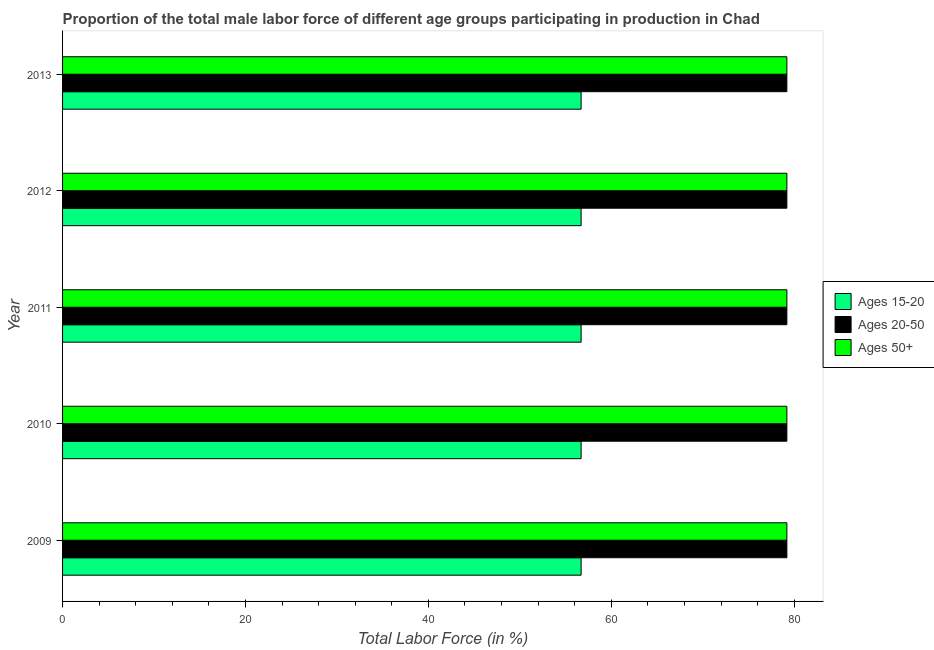How many different coloured bars are there?
Your answer should be compact. 3. What is the label of the 3rd group of bars from the top?
Give a very brief answer. 2011. In how many cases, is the number of bars for a given year not equal to the number of legend labels?
Give a very brief answer. 0. What is the percentage of male labor force within the age group 15-20 in 2010?
Provide a succinct answer. 56.7. Across all years, what is the maximum percentage of male labor force above age 50?
Make the answer very short. 79.2. Across all years, what is the minimum percentage of male labor force within the age group 20-50?
Your answer should be compact. 79.2. In which year was the percentage of male labor force above age 50 maximum?
Provide a short and direct response. 2009. In which year was the percentage of male labor force above age 50 minimum?
Your answer should be very brief. 2009. What is the total percentage of male labor force above age 50 in the graph?
Your answer should be very brief. 396. What is the difference between the percentage of male labor force within the age group 15-20 in 2010 and the percentage of male labor force within the age group 20-50 in 2011?
Your answer should be very brief. -22.5. What is the average percentage of male labor force within the age group 20-50 per year?
Keep it short and to the point. 79.2. In how many years, is the percentage of male labor force within the age group 15-20 greater than 36 %?
Your response must be concise. 5. Is the difference between the percentage of male labor force above age 50 in 2009 and 2013 greater than the difference between the percentage of male labor force within the age group 20-50 in 2009 and 2013?
Make the answer very short. No. What is the difference between the highest and the second highest percentage of male labor force within the age group 20-50?
Your answer should be compact. 0. What is the difference between the highest and the lowest percentage of male labor force above age 50?
Offer a very short reply. 0. Is the sum of the percentage of male labor force within the age group 20-50 in 2012 and 2013 greater than the maximum percentage of male labor force above age 50 across all years?
Make the answer very short. Yes. What does the 2nd bar from the top in 2009 represents?
Your answer should be very brief. Ages 20-50. What does the 1st bar from the bottom in 2013 represents?
Make the answer very short. Ages 15-20. Are all the bars in the graph horizontal?
Your answer should be compact. Yes. How many years are there in the graph?
Provide a short and direct response. 5. What is the difference between two consecutive major ticks on the X-axis?
Keep it short and to the point. 20. Does the graph contain any zero values?
Give a very brief answer. No. Where does the legend appear in the graph?
Make the answer very short. Center right. How many legend labels are there?
Offer a terse response. 3. What is the title of the graph?
Offer a terse response. Proportion of the total male labor force of different age groups participating in production in Chad. Does "Financial account" appear as one of the legend labels in the graph?
Your answer should be very brief. No. What is the label or title of the X-axis?
Offer a very short reply. Total Labor Force (in %). What is the label or title of the Y-axis?
Offer a very short reply. Year. What is the Total Labor Force (in %) in Ages 15-20 in 2009?
Your response must be concise. 56.7. What is the Total Labor Force (in %) in Ages 20-50 in 2009?
Give a very brief answer. 79.2. What is the Total Labor Force (in %) of Ages 50+ in 2009?
Provide a succinct answer. 79.2. What is the Total Labor Force (in %) of Ages 15-20 in 2010?
Your response must be concise. 56.7. What is the Total Labor Force (in %) in Ages 20-50 in 2010?
Your response must be concise. 79.2. What is the Total Labor Force (in %) in Ages 50+ in 2010?
Your answer should be compact. 79.2. What is the Total Labor Force (in %) of Ages 15-20 in 2011?
Ensure brevity in your answer.  56.7. What is the Total Labor Force (in %) of Ages 20-50 in 2011?
Make the answer very short. 79.2. What is the Total Labor Force (in %) of Ages 50+ in 2011?
Keep it short and to the point. 79.2. What is the Total Labor Force (in %) in Ages 15-20 in 2012?
Provide a short and direct response. 56.7. What is the Total Labor Force (in %) in Ages 20-50 in 2012?
Keep it short and to the point. 79.2. What is the Total Labor Force (in %) of Ages 50+ in 2012?
Give a very brief answer. 79.2. What is the Total Labor Force (in %) in Ages 15-20 in 2013?
Your response must be concise. 56.7. What is the Total Labor Force (in %) of Ages 20-50 in 2013?
Your answer should be compact. 79.2. What is the Total Labor Force (in %) in Ages 50+ in 2013?
Offer a very short reply. 79.2. Across all years, what is the maximum Total Labor Force (in %) in Ages 15-20?
Ensure brevity in your answer.  56.7. Across all years, what is the maximum Total Labor Force (in %) in Ages 20-50?
Make the answer very short. 79.2. Across all years, what is the maximum Total Labor Force (in %) in Ages 50+?
Your response must be concise. 79.2. Across all years, what is the minimum Total Labor Force (in %) of Ages 15-20?
Keep it short and to the point. 56.7. Across all years, what is the minimum Total Labor Force (in %) of Ages 20-50?
Provide a succinct answer. 79.2. Across all years, what is the minimum Total Labor Force (in %) of Ages 50+?
Offer a very short reply. 79.2. What is the total Total Labor Force (in %) in Ages 15-20 in the graph?
Provide a succinct answer. 283.5. What is the total Total Labor Force (in %) in Ages 20-50 in the graph?
Provide a short and direct response. 396. What is the total Total Labor Force (in %) of Ages 50+ in the graph?
Ensure brevity in your answer.  396. What is the difference between the Total Labor Force (in %) of Ages 15-20 in 2009 and that in 2010?
Ensure brevity in your answer.  0. What is the difference between the Total Labor Force (in %) of Ages 50+ in 2009 and that in 2011?
Provide a short and direct response. 0. What is the difference between the Total Labor Force (in %) of Ages 15-20 in 2009 and that in 2012?
Ensure brevity in your answer.  0. What is the difference between the Total Labor Force (in %) in Ages 20-50 in 2009 and that in 2012?
Give a very brief answer. 0. What is the difference between the Total Labor Force (in %) of Ages 15-20 in 2009 and that in 2013?
Offer a very short reply. 0. What is the difference between the Total Labor Force (in %) in Ages 50+ in 2009 and that in 2013?
Provide a short and direct response. 0. What is the difference between the Total Labor Force (in %) of Ages 15-20 in 2010 and that in 2013?
Your answer should be compact. 0. What is the difference between the Total Labor Force (in %) in Ages 50+ in 2010 and that in 2013?
Keep it short and to the point. 0. What is the difference between the Total Labor Force (in %) of Ages 20-50 in 2011 and that in 2012?
Your response must be concise. 0. What is the difference between the Total Labor Force (in %) in Ages 15-20 in 2011 and that in 2013?
Give a very brief answer. 0. What is the difference between the Total Labor Force (in %) of Ages 20-50 in 2011 and that in 2013?
Offer a terse response. 0. What is the difference between the Total Labor Force (in %) of Ages 50+ in 2011 and that in 2013?
Ensure brevity in your answer.  0. What is the difference between the Total Labor Force (in %) of Ages 15-20 in 2012 and that in 2013?
Your answer should be very brief. 0. What is the difference between the Total Labor Force (in %) of Ages 20-50 in 2012 and that in 2013?
Your answer should be very brief. 0. What is the difference between the Total Labor Force (in %) of Ages 15-20 in 2009 and the Total Labor Force (in %) of Ages 20-50 in 2010?
Ensure brevity in your answer.  -22.5. What is the difference between the Total Labor Force (in %) in Ages 15-20 in 2009 and the Total Labor Force (in %) in Ages 50+ in 2010?
Ensure brevity in your answer.  -22.5. What is the difference between the Total Labor Force (in %) of Ages 15-20 in 2009 and the Total Labor Force (in %) of Ages 20-50 in 2011?
Your answer should be very brief. -22.5. What is the difference between the Total Labor Force (in %) in Ages 15-20 in 2009 and the Total Labor Force (in %) in Ages 50+ in 2011?
Your answer should be very brief. -22.5. What is the difference between the Total Labor Force (in %) of Ages 20-50 in 2009 and the Total Labor Force (in %) of Ages 50+ in 2011?
Keep it short and to the point. 0. What is the difference between the Total Labor Force (in %) of Ages 15-20 in 2009 and the Total Labor Force (in %) of Ages 20-50 in 2012?
Your answer should be very brief. -22.5. What is the difference between the Total Labor Force (in %) of Ages 15-20 in 2009 and the Total Labor Force (in %) of Ages 50+ in 2012?
Provide a short and direct response. -22.5. What is the difference between the Total Labor Force (in %) of Ages 20-50 in 2009 and the Total Labor Force (in %) of Ages 50+ in 2012?
Provide a succinct answer. 0. What is the difference between the Total Labor Force (in %) of Ages 15-20 in 2009 and the Total Labor Force (in %) of Ages 20-50 in 2013?
Give a very brief answer. -22.5. What is the difference between the Total Labor Force (in %) of Ages 15-20 in 2009 and the Total Labor Force (in %) of Ages 50+ in 2013?
Provide a succinct answer. -22.5. What is the difference between the Total Labor Force (in %) in Ages 15-20 in 2010 and the Total Labor Force (in %) in Ages 20-50 in 2011?
Your answer should be very brief. -22.5. What is the difference between the Total Labor Force (in %) in Ages 15-20 in 2010 and the Total Labor Force (in %) in Ages 50+ in 2011?
Give a very brief answer. -22.5. What is the difference between the Total Labor Force (in %) of Ages 20-50 in 2010 and the Total Labor Force (in %) of Ages 50+ in 2011?
Your response must be concise. 0. What is the difference between the Total Labor Force (in %) in Ages 15-20 in 2010 and the Total Labor Force (in %) in Ages 20-50 in 2012?
Give a very brief answer. -22.5. What is the difference between the Total Labor Force (in %) of Ages 15-20 in 2010 and the Total Labor Force (in %) of Ages 50+ in 2012?
Offer a very short reply. -22.5. What is the difference between the Total Labor Force (in %) in Ages 20-50 in 2010 and the Total Labor Force (in %) in Ages 50+ in 2012?
Offer a terse response. 0. What is the difference between the Total Labor Force (in %) in Ages 15-20 in 2010 and the Total Labor Force (in %) in Ages 20-50 in 2013?
Provide a succinct answer. -22.5. What is the difference between the Total Labor Force (in %) of Ages 15-20 in 2010 and the Total Labor Force (in %) of Ages 50+ in 2013?
Offer a very short reply. -22.5. What is the difference between the Total Labor Force (in %) in Ages 15-20 in 2011 and the Total Labor Force (in %) in Ages 20-50 in 2012?
Your answer should be very brief. -22.5. What is the difference between the Total Labor Force (in %) of Ages 15-20 in 2011 and the Total Labor Force (in %) of Ages 50+ in 2012?
Your answer should be compact. -22.5. What is the difference between the Total Labor Force (in %) of Ages 20-50 in 2011 and the Total Labor Force (in %) of Ages 50+ in 2012?
Keep it short and to the point. 0. What is the difference between the Total Labor Force (in %) of Ages 15-20 in 2011 and the Total Labor Force (in %) of Ages 20-50 in 2013?
Your answer should be compact. -22.5. What is the difference between the Total Labor Force (in %) in Ages 15-20 in 2011 and the Total Labor Force (in %) in Ages 50+ in 2013?
Your response must be concise. -22.5. What is the difference between the Total Labor Force (in %) of Ages 20-50 in 2011 and the Total Labor Force (in %) of Ages 50+ in 2013?
Offer a very short reply. 0. What is the difference between the Total Labor Force (in %) in Ages 15-20 in 2012 and the Total Labor Force (in %) in Ages 20-50 in 2013?
Give a very brief answer. -22.5. What is the difference between the Total Labor Force (in %) in Ages 15-20 in 2012 and the Total Labor Force (in %) in Ages 50+ in 2013?
Your response must be concise. -22.5. What is the difference between the Total Labor Force (in %) of Ages 20-50 in 2012 and the Total Labor Force (in %) of Ages 50+ in 2013?
Provide a succinct answer. 0. What is the average Total Labor Force (in %) of Ages 15-20 per year?
Keep it short and to the point. 56.7. What is the average Total Labor Force (in %) of Ages 20-50 per year?
Your response must be concise. 79.2. What is the average Total Labor Force (in %) of Ages 50+ per year?
Provide a short and direct response. 79.2. In the year 2009, what is the difference between the Total Labor Force (in %) of Ages 15-20 and Total Labor Force (in %) of Ages 20-50?
Give a very brief answer. -22.5. In the year 2009, what is the difference between the Total Labor Force (in %) in Ages 15-20 and Total Labor Force (in %) in Ages 50+?
Your answer should be very brief. -22.5. In the year 2009, what is the difference between the Total Labor Force (in %) of Ages 20-50 and Total Labor Force (in %) of Ages 50+?
Ensure brevity in your answer.  0. In the year 2010, what is the difference between the Total Labor Force (in %) of Ages 15-20 and Total Labor Force (in %) of Ages 20-50?
Keep it short and to the point. -22.5. In the year 2010, what is the difference between the Total Labor Force (in %) of Ages 15-20 and Total Labor Force (in %) of Ages 50+?
Give a very brief answer. -22.5. In the year 2010, what is the difference between the Total Labor Force (in %) of Ages 20-50 and Total Labor Force (in %) of Ages 50+?
Keep it short and to the point. 0. In the year 2011, what is the difference between the Total Labor Force (in %) in Ages 15-20 and Total Labor Force (in %) in Ages 20-50?
Offer a terse response. -22.5. In the year 2011, what is the difference between the Total Labor Force (in %) in Ages 15-20 and Total Labor Force (in %) in Ages 50+?
Offer a terse response. -22.5. In the year 2012, what is the difference between the Total Labor Force (in %) of Ages 15-20 and Total Labor Force (in %) of Ages 20-50?
Keep it short and to the point. -22.5. In the year 2012, what is the difference between the Total Labor Force (in %) in Ages 15-20 and Total Labor Force (in %) in Ages 50+?
Make the answer very short. -22.5. In the year 2012, what is the difference between the Total Labor Force (in %) of Ages 20-50 and Total Labor Force (in %) of Ages 50+?
Make the answer very short. 0. In the year 2013, what is the difference between the Total Labor Force (in %) in Ages 15-20 and Total Labor Force (in %) in Ages 20-50?
Keep it short and to the point. -22.5. In the year 2013, what is the difference between the Total Labor Force (in %) of Ages 15-20 and Total Labor Force (in %) of Ages 50+?
Provide a short and direct response. -22.5. In the year 2013, what is the difference between the Total Labor Force (in %) in Ages 20-50 and Total Labor Force (in %) in Ages 50+?
Your response must be concise. 0. What is the ratio of the Total Labor Force (in %) of Ages 15-20 in 2009 to that in 2010?
Offer a terse response. 1. What is the ratio of the Total Labor Force (in %) in Ages 20-50 in 2009 to that in 2010?
Give a very brief answer. 1. What is the ratio of the Total Labor Force (in %) of Ages 50+ in 2009 to that in 2010?
Your answer should be compact. 1. What is the ratio of the Total Labor Force (in %) in Ages 20-50 in 2009 to that in 2011?
Provide a succinct answer. 1. What is the ratio of the Total Labor Force (in %) of Ages 50+ in 2009 to that in 2011?
Give a very brief answer. 1. What is the ratio of the Total Labor Force (in %) of Ages 20-50 in 2009 to that in 2012?
Keep it short and to the point. 1. What is the ratio of the Total Labor Force (in %) of Ages 50+ in 2009 to that in 2012?
Make the answer very short. 1. What is the ratio of the Total Labor Force (in %) in Ages 15-20 in 2009 to that in 2013?
Your answer should be very brief. 1. What is the ratio of the Total Labor Force (in %) in Ages 15-20 in 2010 to that in 2011?
Your response must be concise. 1. What is the ratio of the Total Labor Force (in %) of Ages 20-50 in 2010 to that in 2011?
Keep it short and to the point. 1. What is the ratio of the Total Labor Force (in %) in Ages 50+ in 2010 to that in 2011?
Ensure brevity in your answer.  1. What is the ratio of the Total Labor Force (in %) in Ages 15-20 in 2010 to that in 2012?
Your response must be concise. 1. What is the ratio of the Total Labor Force (in %) in Ages 50+ in 2010 to that in 2012?
Your response must be concise. 1. What is the ratio of the Total Labor Force (in %) of Ages 50+ in 2010 to that in 2013?
Your response must be concise. 1. What is the ratio of the Total Labor Force (in %) of Ages 15-20 in 2011 to that in 2012?
Your response must be concise. 1. What is the ratio of the Total Labor Force (in %) in Ages 50+ in 2011 to that in 2012?
Keep it short and to the point. 1. What is the ratio of the Total Labor Force (in %) in Ages 15-20 in 2011 to that in 2013?
Your answer should be very brief. 1. What is the ratio of the Total Labor Force (in %) of Ages 15-20 in 2012 to that in 2013?
Your answer should be compact. 1. What is the difference between the highest and the second highest Total Labor Force (in %) of Ages 15-20?
Provide a short and direct response. 0. What is the difference between the highest and the second highest Total Labor Force (in %) in Ages 50+?
Offer a very short reply. 0. What is the difference between the highest and the lowest Total Labor Force (in %) of Ages 15-20?
Ensure brevity in your answer.  0. What is the difference between the highest and the lowest Total Labor Force (in %) in Ages 20-50?
Give a very brief answer. 0. What is the difference between the highest and the lowest Total Labor Force (in %) of Ages 50+?
Make the answer very short. 0. 